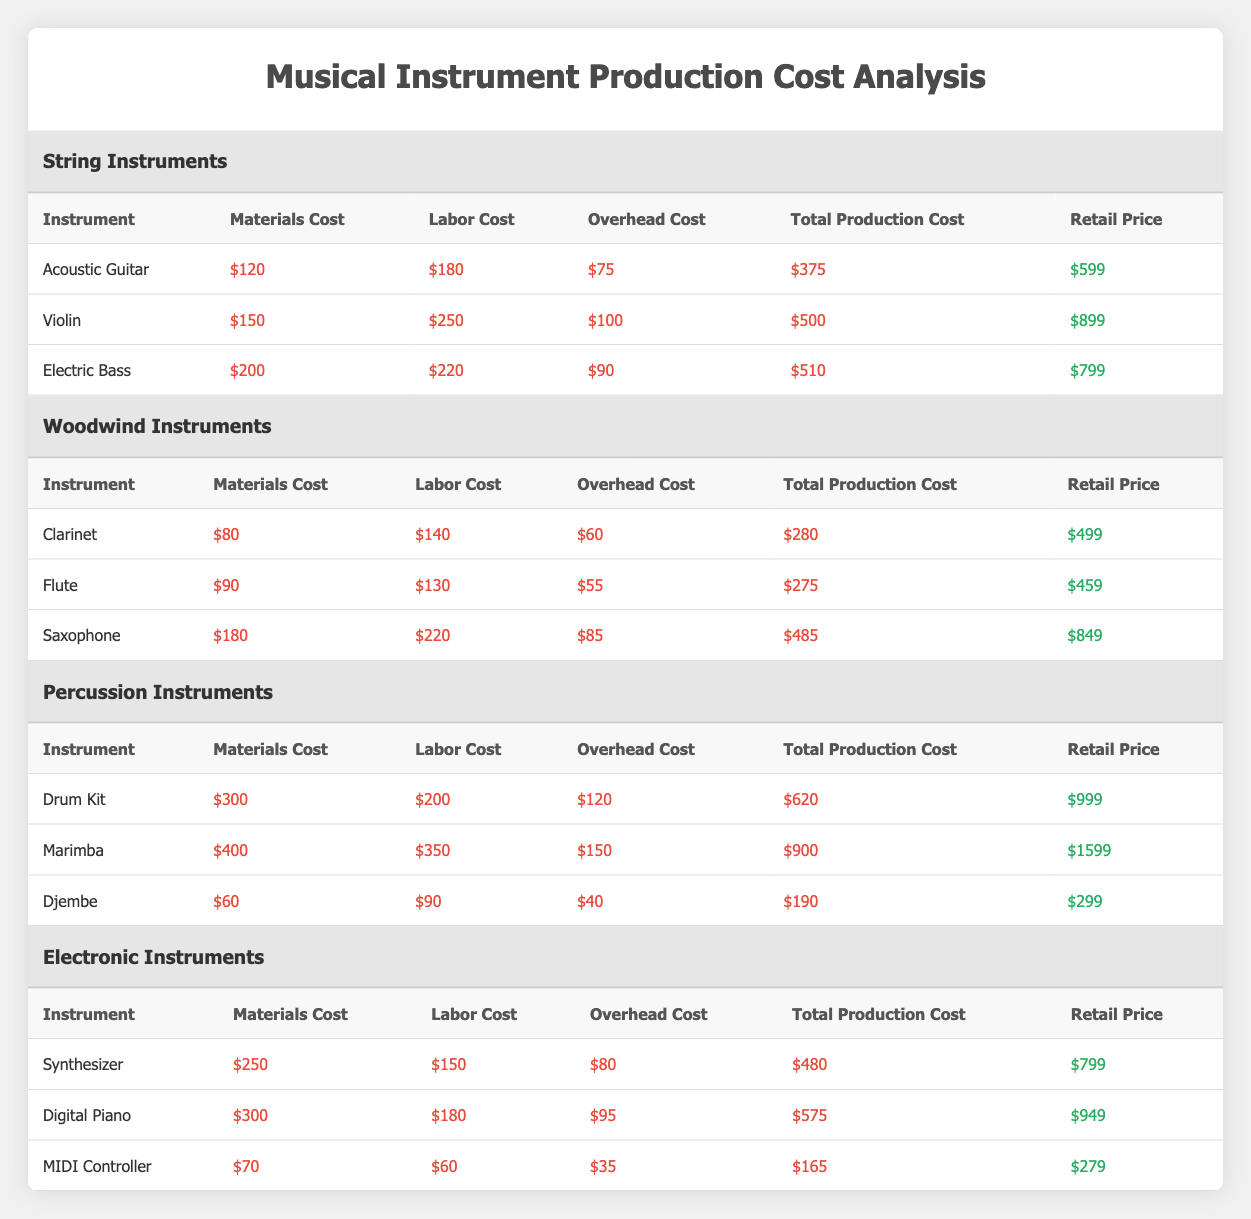What is the retail price of the Violin? The retail price of the Violin is listed directly under the "Retail Price" column in the "String Instruments" section of the table.
Answer: 899 Which instrument has the highest total production cost? The highest total production cost can be found by comparing the "Total Production Cost" values of all instruments listed in the table. The Marimba has the highest total production cost at 900.
Answer: 900 Is the materials cost of the Electric Bass higher than that of the Acoustic Guitar? By comparing the "Materials Cost" values for both instruments, the Electric Bass costs 200 while the Acoustic Guitar costs 120. Thus, yes, the Electric Bass's cost is higher.
Answer: Yes What is the average total production cost of all Percussion Instruments? The total production costs for Percussion Instruments are 620 for the Drum Kit, 900 for the Marimba, and 190 for the Djembe. Adding these gives 620 + 900 + 190 = 1710. Dividing by the number of instruments (3), the average is 1710/3 = 570.
Answer: 570 Does the Clarinet retail price exceed the retail price of the MIDI Controller? The retail price of the Clarinet is 499, and the retail price of the MIDI Controller is 279. Since 499 is greater than 279, the statement is true.
Answer: Yes If we combine the total production costs of all String Instruments, what is the total? The total production costs for String Instruments are 375 for the Acoustic Guitar, 500 for the Violin, and 510 for the Electric Bass. Adding these values gives 375 + 500 + 510 = 1385.
Answer: 1385 Which category includes the instrument with the highest retail price? By checking the retail prices across the categories, the Marimba has the highest retail price at 1599, which falls under Percussion Instruments.
Answer: Percussion Instruments What is the difference between the total production cost of the Synthesizer and the Djembe? The total production cost of the Synthesizer is 480 and for the Djembe, it is 190. The difference can be calculated as 480 - 190 = 290.
Answer: 290 